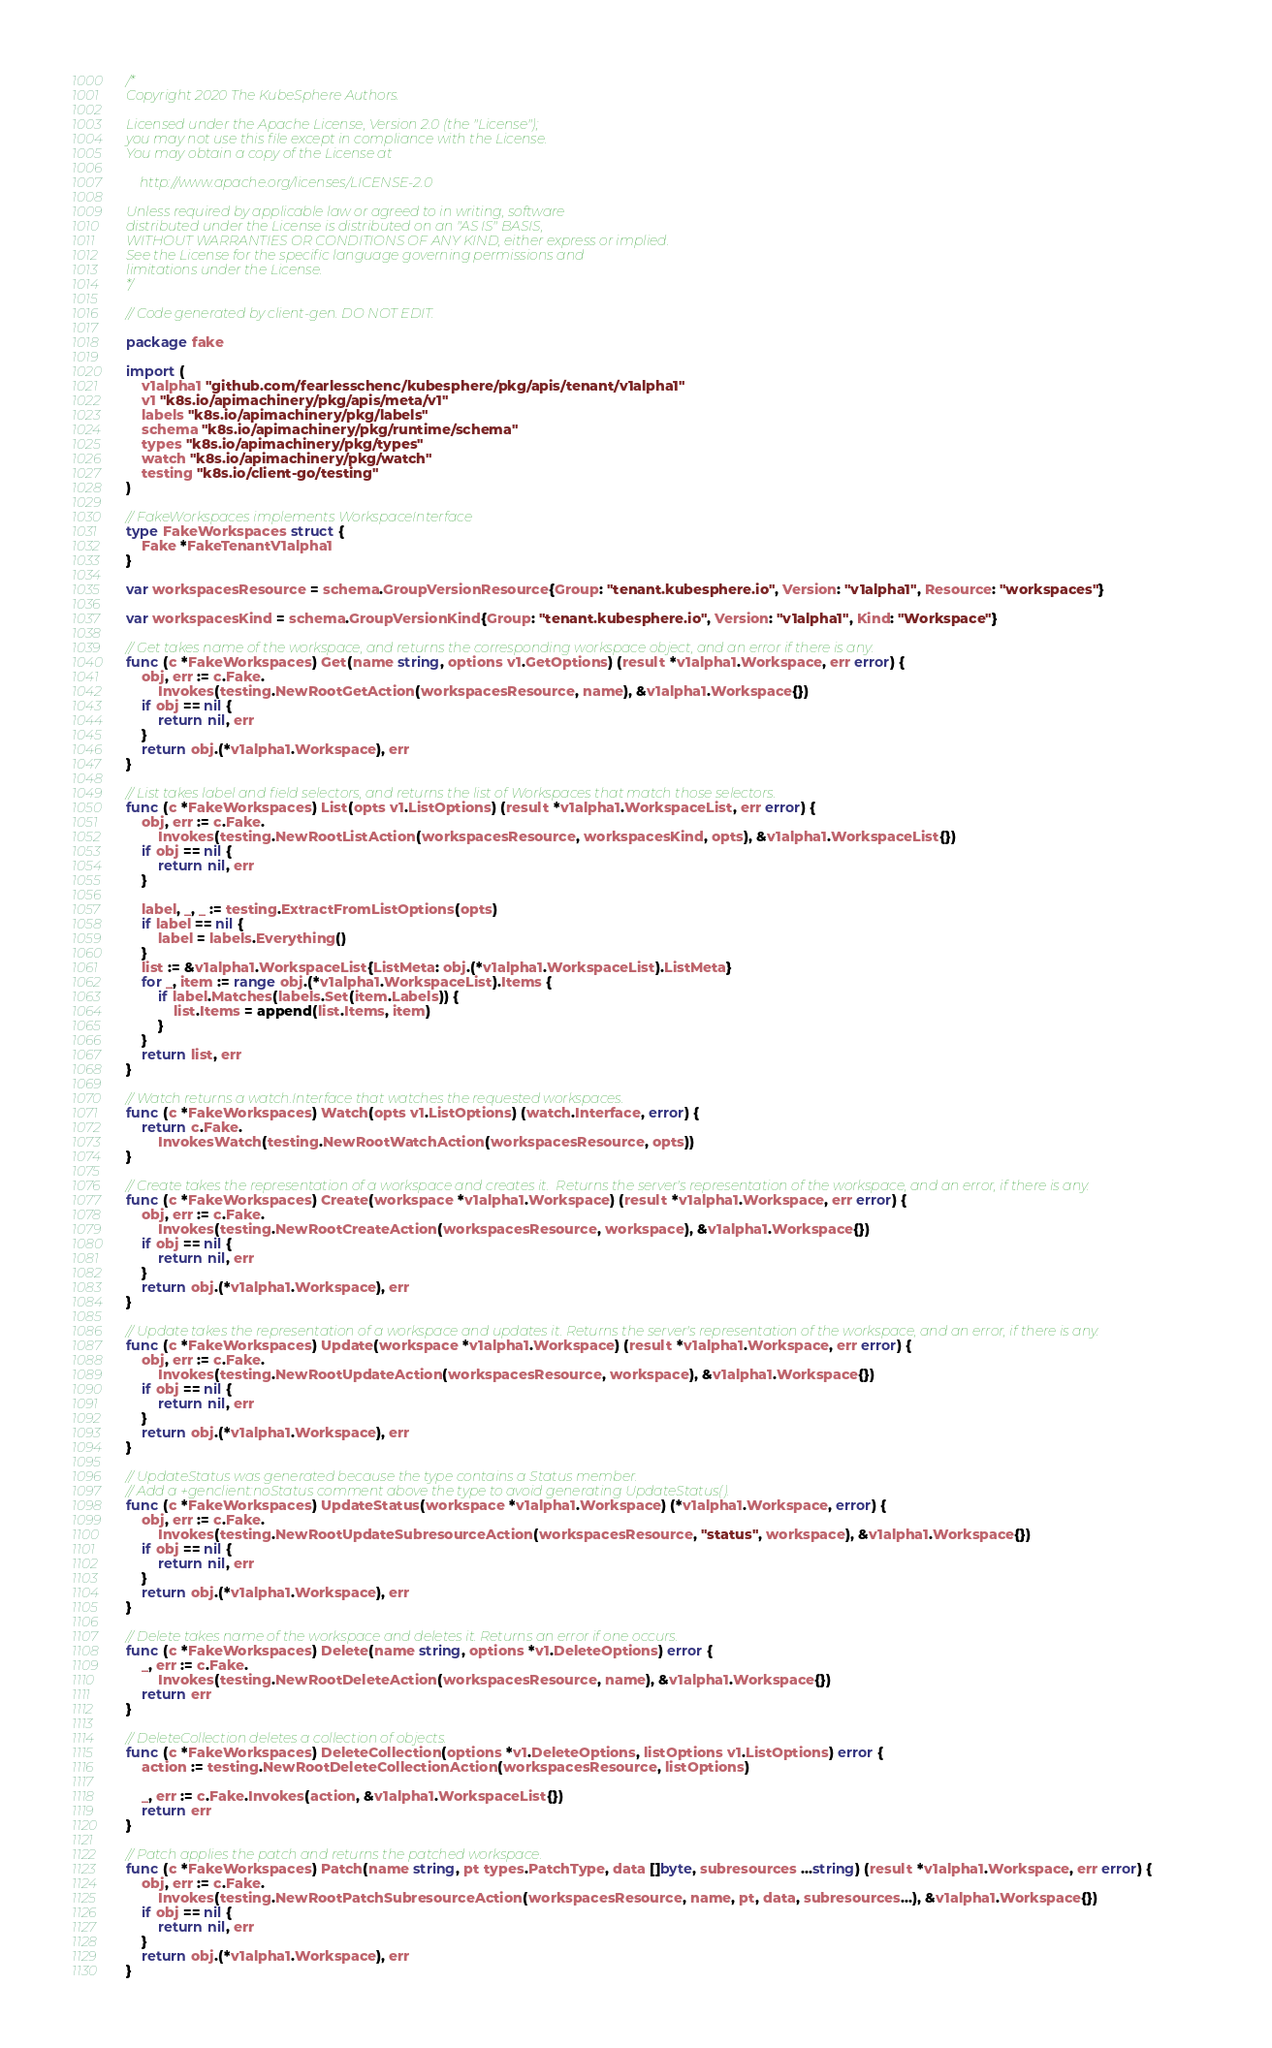Convert code to text. <code><loc_0><loc_0><loc_500><loc_500><_Go_>/*
Copyright 2020 The KubeSphere Authors.

Licensed under the Apache License, Version 2.0 (the "License");
you may not use this file except in compliance with the License.
You may obtain a copy of the License at

    http://www.apache.org/licenses/LICENSE-2.0

Unless required by applicable law or agreed to in writing, software
distributed under the License is distributed on an "AS IS" BASIS,
WITHOUT WARRANTIES OR CONDITIONS OF ANY KIND, either express or implied.
See the License for the specific language governing permissions and
limitations under the License.
*/

// Code generated by client-gen. DO NOT EDIT.

package fake

import (
	v1alpha1 "github.com/fearlesschenc/kubesphere/pkg/apis/tenant/v1alpha1"
	v1 "k8s.io/apimachinery/pkg/apis/meta/v1"
	labels "k8s.io/apimachinery/pkg/labels"
	schema "k8s.io/apimachinery/pkg/runtime/schema"
	types "k8s.io/apimachinery/pkg/types"
	watch "k8s.io/apimachinery/pkg/watch"
	testing "k8s.io/client-go/testing"
)

// FakeWorkspaces implements WorkspaceInterface
type FakeWorkspaces struct {
	Fake *FakeTenantV1alpha1
}

var workspacesResource = schema.GroupVersionResource{Group: "tenant.kubesphere.io", Version: "v1alpha1", Resource: "workspaces"}

var workspacesKind = schema.GroupVersionKind{Group: "tenant.kubesphere.io", Version: "v1alpha1", Kind: "Workspace"}

// Get takes name of the workspace, and returns the corresponding workspace object, and an error if there is any.
func (c *FakeWorkspaces) Get(name string, options v1.GetOptions) (result *v1alpha1.Workspace, err error) {
	obj, err := c.Fake.
		Invokes(testing.NewRootGetAction(workspacesResource, name), &v1alpha1.Workspace{})
	if obj == nil {
		return nil, err
	}
	return obj.(*v1alpha1.Workspace), err
}

// List takes label and field selectors, and returns the list of Workspaces that match those selectors.
func (c *FakeWorkspaces) List(opts v1.ListOptions) (result *v1alpha1.WorkspaceList, err error) {
	obj, err := c.Fake.
		Invokes(testing.NewRootListAction(workspacesResource, workspacesKind, opts), &v1alpha1.WorkspaceList{})
	if obj == nil {
		return nil, err
	}

	label, _, _ := testing.ExtractFromListOptions(opts)
	if label == nil {
		label = labels.Everything()
	}
	list := &v1alpha1.WorkspaceList{ListMeta: obj.(*v1alpha1.WorkspaceList).ListMeta}
	for _, item := range obj.(*v1alpha1.WorkspaceList).Items {
		if label.Matches(labels.Set(item.Labels)) {
			list.Items = append(list.Items, item)
		}
	}
	return list, err
}

// Watch returns a watch.Interface that watches the requested workspaces.
func (c *FakeWorkspaces) Watch(opts v1.ListOptions) (watch.Interface, error) {
	return c.Fake.
		InvokesWatch(testing.NewRootWatchAction(workspacesResource, opts))
}

// Create takes the representation of a workspace and creates it.  Returns the server's representation of the workspace, and an error, if there is any.
func (c *FakeWorkspaces) Create(workspace *v1alpha1.Workspace) (result *v1alpha1.Workspace, err error) {
	obj, err := c.Fake.
		Invokes(testing.NewRootCreateAction(workspacesResource, workspace), &v1alpha1.Workspace{})
	if obj == nil {
		return nil, err
	}
	return obj.(*v1alpha1.Workspace), err
}

// Update takes the representation of a workspace and updates it. Returns the server's representation of the workspace, and an error, if there is any.
func (c *FakeWorkspaces) Update(workspace *v1alpha1.Workspace) (result *v1alpha1.Workspace, err error) {
	obj, err := c.Fake.
		Invokes(testing.NewRootUpdateAction(workspacesResource, workspace), &v1alpha1.Workspace{})
	if obj == nil {
		return nil, err
	}
	return obj.(*v1alpha1.Workspace), err
}

// UpdateStatus was generated because the type contains a Status member.
// Add a +genclient:noStatus comment above the type to avoid generating UpdateStatus().
func (c *FakeWorkspaces) UpdateStatus(workspace *v1alpha1.Workspace) (*v1alpha1.Workspace, error) {
	obj, err := c.Fake.
		Invokes(testing.NewRootUpdateSubresourceAction(workspacesResource, "status", workspace), &v1alpha1.Workspace{})
	if obj == nil {
		return nil, err
	}
	return obj.(*v1alpha1.Workspace), err
}

// Delete takes name of the workspace and deletes it. Returns an error if one occurs.
func (c *FakeWorkspaces) Delete(name string, options *v1.DeleteOptions) error {
	_, err := c.Fake.
		Invokes(testing.NewRootDeleteAction(workspacesResource, name), &v1alpha1.Workspace{})
	return err
}

// DeleteCollection deletes a collection of objects.
func (c *FakeWorkspaces) DeleteCollection(options *v1.DeleteOptions, listOptions v1.ListOptions) error {
	action := testing.NewRootDeleteCollectionAction(workspacesResource, listOptions)

	_, err := c.Fake.Invokes(action, &v1alpha1.WorkspaceList{})
	return err
}

// Patch applies the patch and returns the patched workspace.
func (c *FakeWorkspaces) Patch(name string, pt types.PatchType, data []byte, subresources ...string) (result *v1alpha1.Workspace, err error) {
	obj, err := c.Fake.
		Invokes(testing.NewRootPatchSubresourceAction(workspacesResource, name, pt, data, subresources...), &v1alpha1.Workspace{})
	if obj == nil {
		return nil, err
	}
	return obj.(*v1alpha1.Workspace), err
}
</code> 